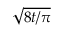Convert formula to latex. <formula><loc_0><loc_0><loc_500><loc_500>\sqrt { 8 t / \pi }</formula> 